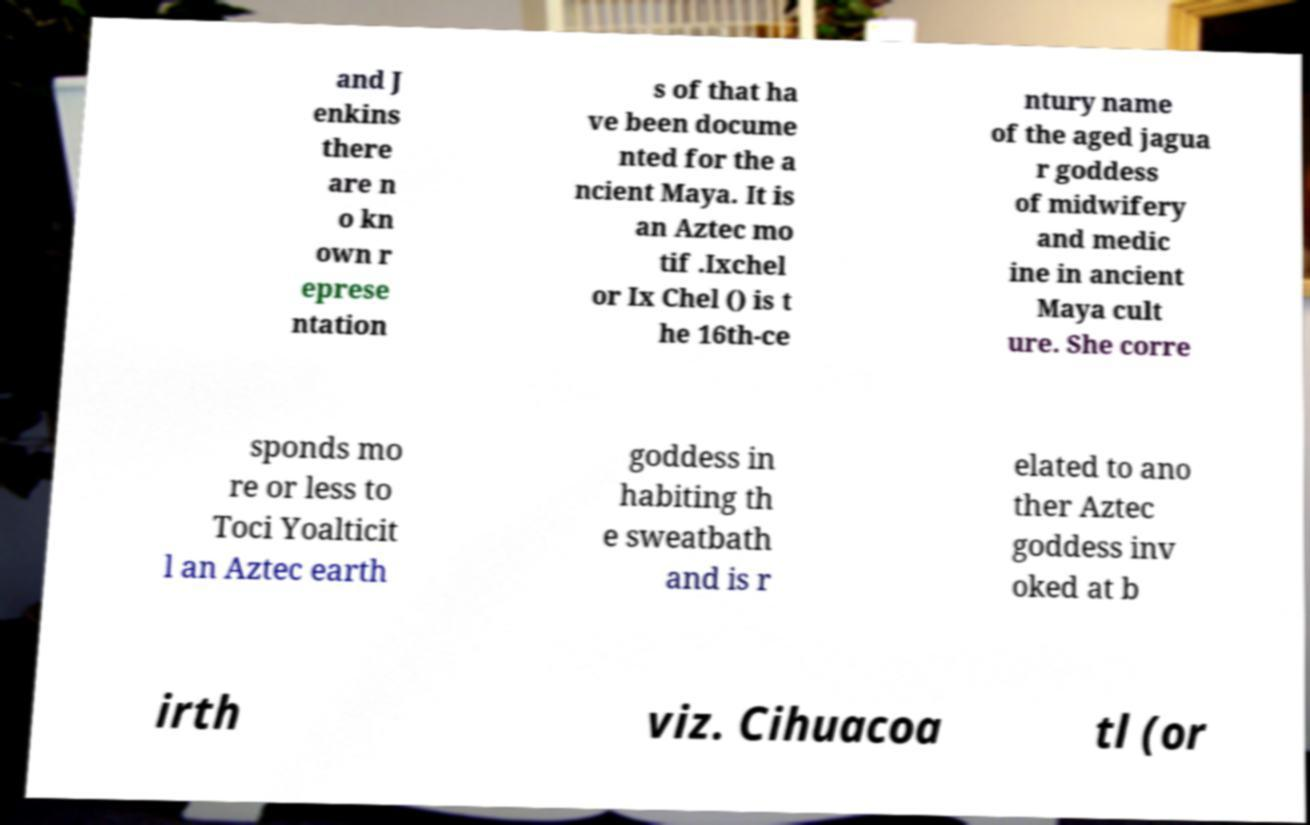Could you assist in decoding the text presented in this image and type it out clearly? and J enkins there are n o kn own r eprese ntation s of that ha ve been docume nted for the a ncient Maya. It is an Aztec mo tif .Ixchel or Ix Chel () is t he 16th-ce ntury name of the aged jagua r goddess of midwifery and medic ine in ancient Maya cult ure. She corre sponds mo re or less to Toci Yoalticit l an Aztec earth goddess in habiting th e sweatbath and is r elated to ano ther Aztec goddess inv oked at b irth viz. Cihuacoa tl (or 